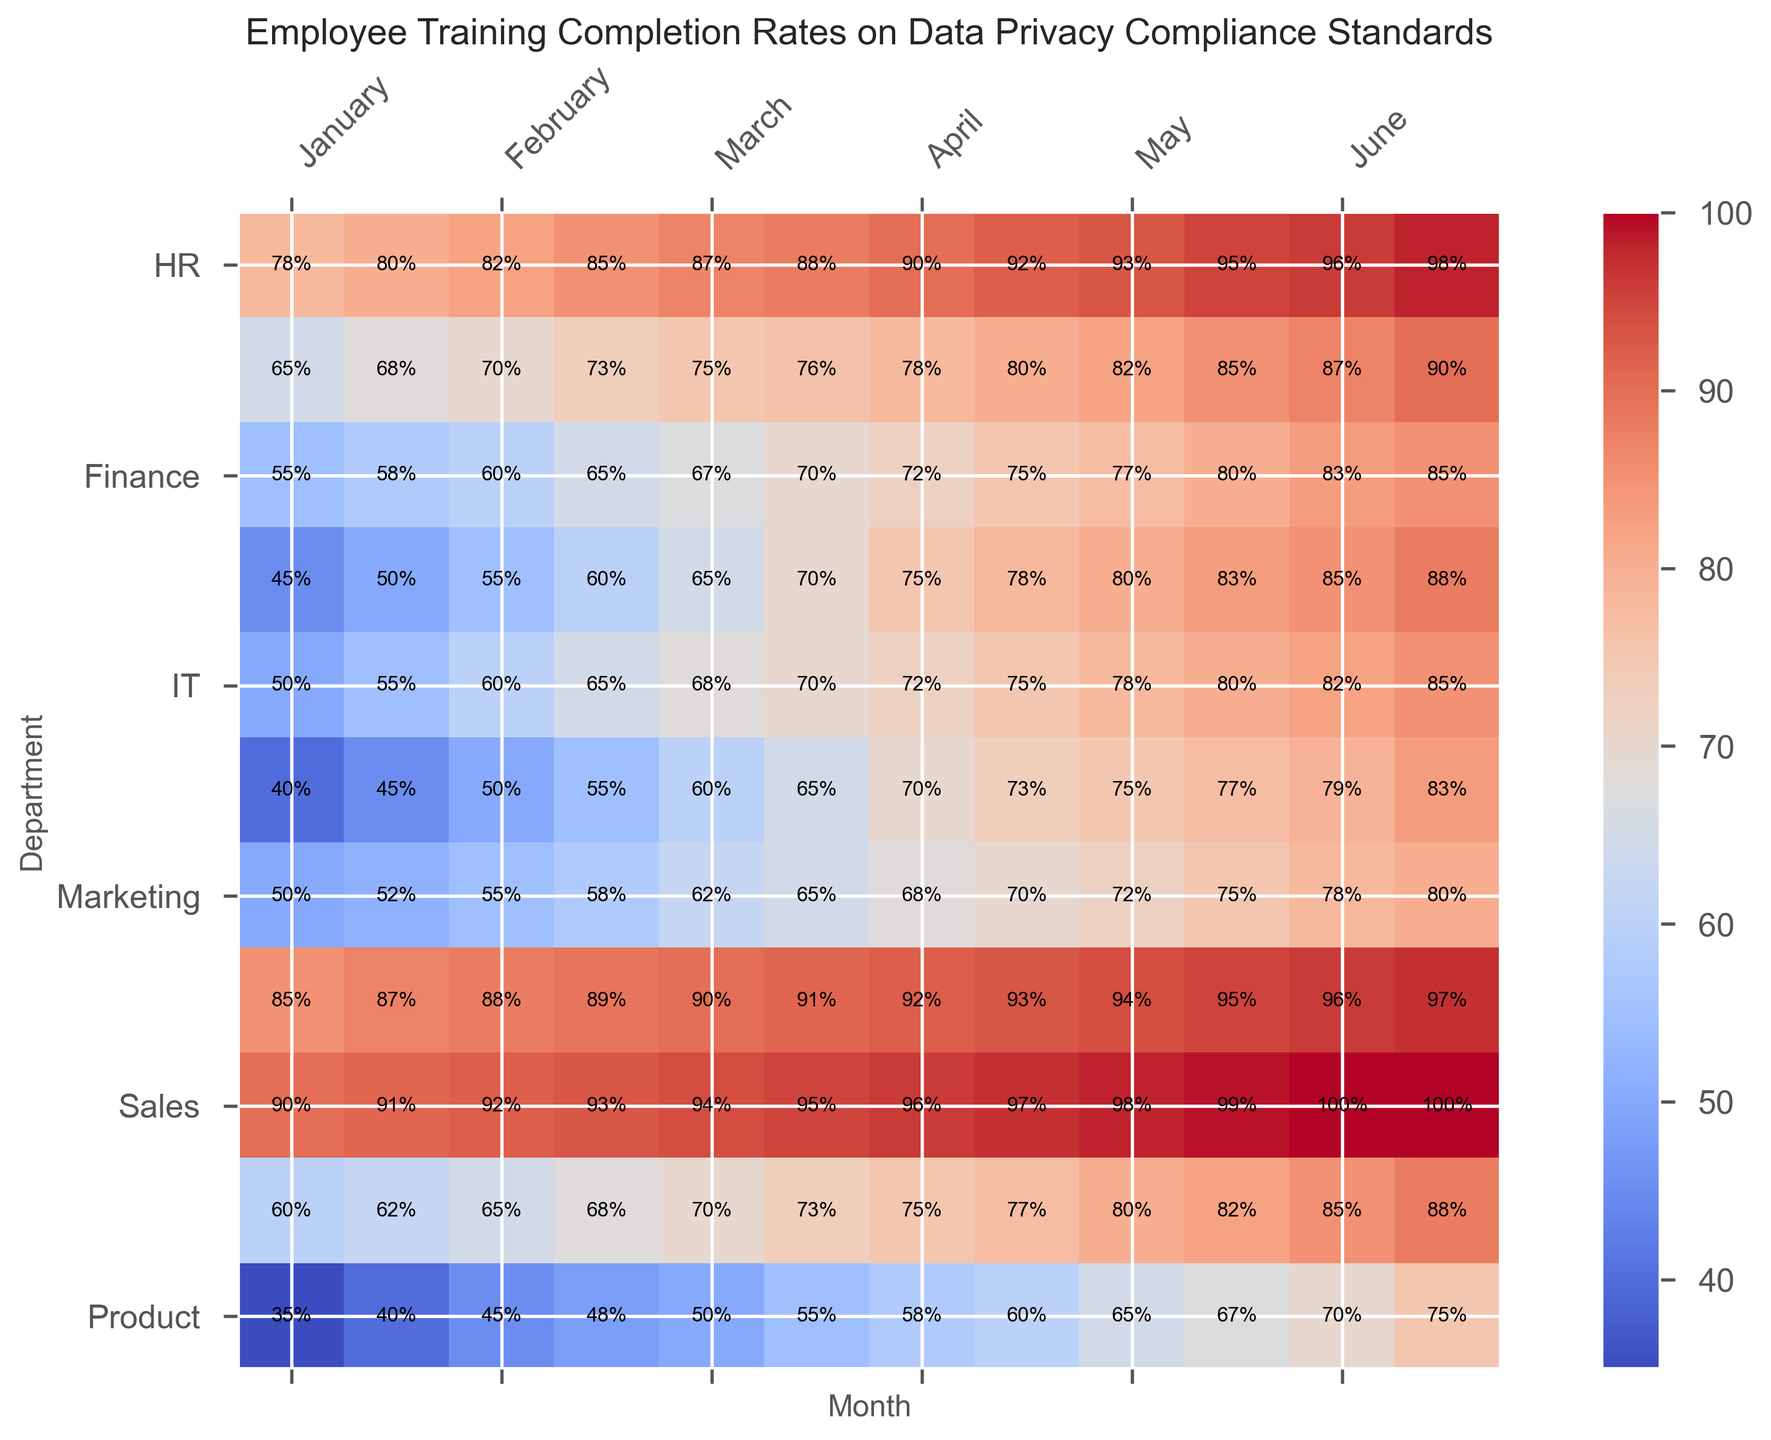What is the highest training completion rate in December? Look at the December column and identify the highest value. The highest value in the December column is 100%.
Answer: 100% Which department showed the greatest increase in training completion rates from January to December? Calculate the difference between December and January values for each department and identify the maximum difference. Compliance department increased from 90% to 100%, a difference of 10%.
Answer: Compliance Which department consistently had the lowest training completion rate over the year? Identify the department with the overall lowest values throughout the months. R&D has the lowest values over the year.
Answer: R&D In which month did the IT department surpass the 80% training completion rate? Identify the months where IT's training rate is above 80%. IT crosses 80% in October with 83%.
Answer: October What is the average training completion rate for the Sales department over the year? Sum all the monthly percentages for Sales and divide by 12. (50 + 55 + 60 + 65 + 68 + 70 + 72 + 75 + 78 + 80 + 82 + 85) / 12 = 71.42%
Answer: 71.42% Which two departments have similar training rates in November, and what are they? Compare each department's November values and identify similar rates. Legal and HR have 96% in November.
Answer: Legal and HR, 96% How does the training completion rate of the Finance department in June compare to the Operations department in the same month? Compare the values for Finance and Operations in June. Finance has 76% and Operations has 65% in June.
Answer: Finance is higher What is the median completion rate in August across all departments? List the August values in ascending order and find the middle value. August values: 60, 70, 75, 75, 77, 78, 78, 80, 92, 93, 97. The median is 77%.
Answer: 77% Which month shows the greatest overall improvement in training rates from the previous month? Calculate the month-to-month difference for each department and find the month with the highest average increase. From March to April, most departments show notable increases.
Answer: April Are there any months where all departments have a training rate above 50%? Check each month's values to see if all departments are above 50%. From June to December, all departments exceed 50%.
Answer: June to December 